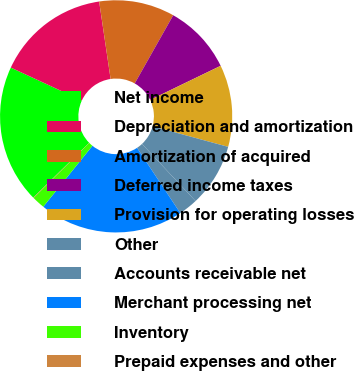<chart> <loc_0><loc_0><loc_500><loc_500><pie_chart><fcel>Net income<fcel>Depreciation and amortization<fcel>Amortization of acquired<fcel>Deferred income taxes<fcel>Provision for operating losses<fcel>Other<fcel>Accounts receivable net<fcel>Merchant processing net<fcel>Inventory<fcel>Prepaid expenses and other<nl><fcel>19.24%<fcel>15.76%<fcel>10.52%<fcel>9.65%<fcel>11.4%<fcel>8.78%<fcel>2.67%<fcel>20.12%<fcel>1.8%<fcel>0.06%<nl></chart> 